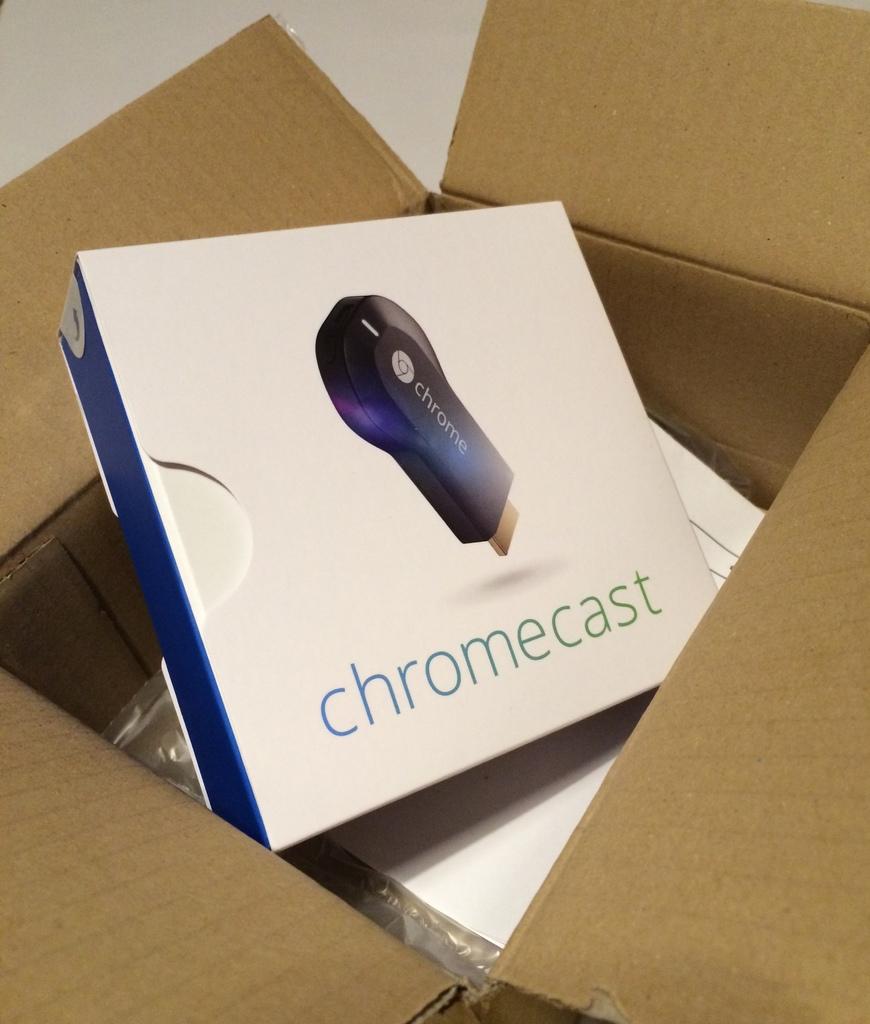What is the product?
Provide a succinct answer. Chromecast. What´s the company of this product?
Your answer should be very brief. Chromecast. 